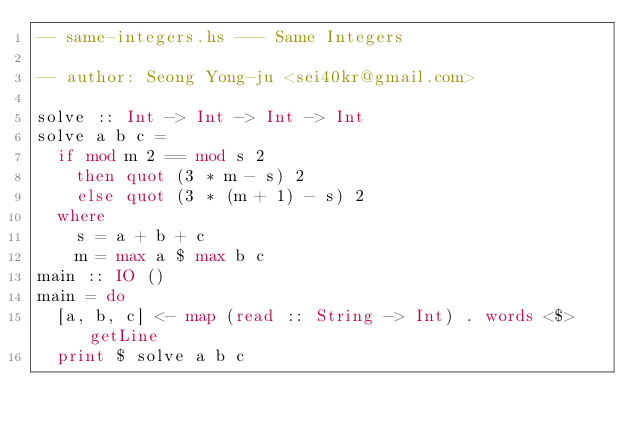Convert code to text. <code><loc_0><loc_0><loc_500><loc_500><_Haskell_>-- same-integers.hs --- Same Integers

-- author: Seong Yong-ju <sei40kr@gmail.com>

solve :: Int -> Int -> Int -> Int
solve a b c =
  if mod m 2 == mod s 2
    then quot (3 * m - s) 2
    else quot (3 * (m + 1) - s) 2
  where
    s = a + b + c
    m = max a $ max b c
main :: IO ()
main = do
  [a, b, c] <- map (read :: String -> Int) . words <$> getLine
  print $ solve a b c
</code> 